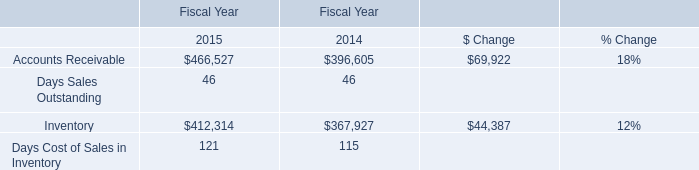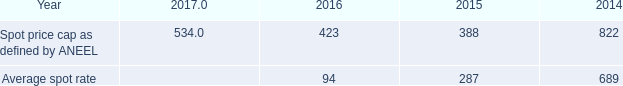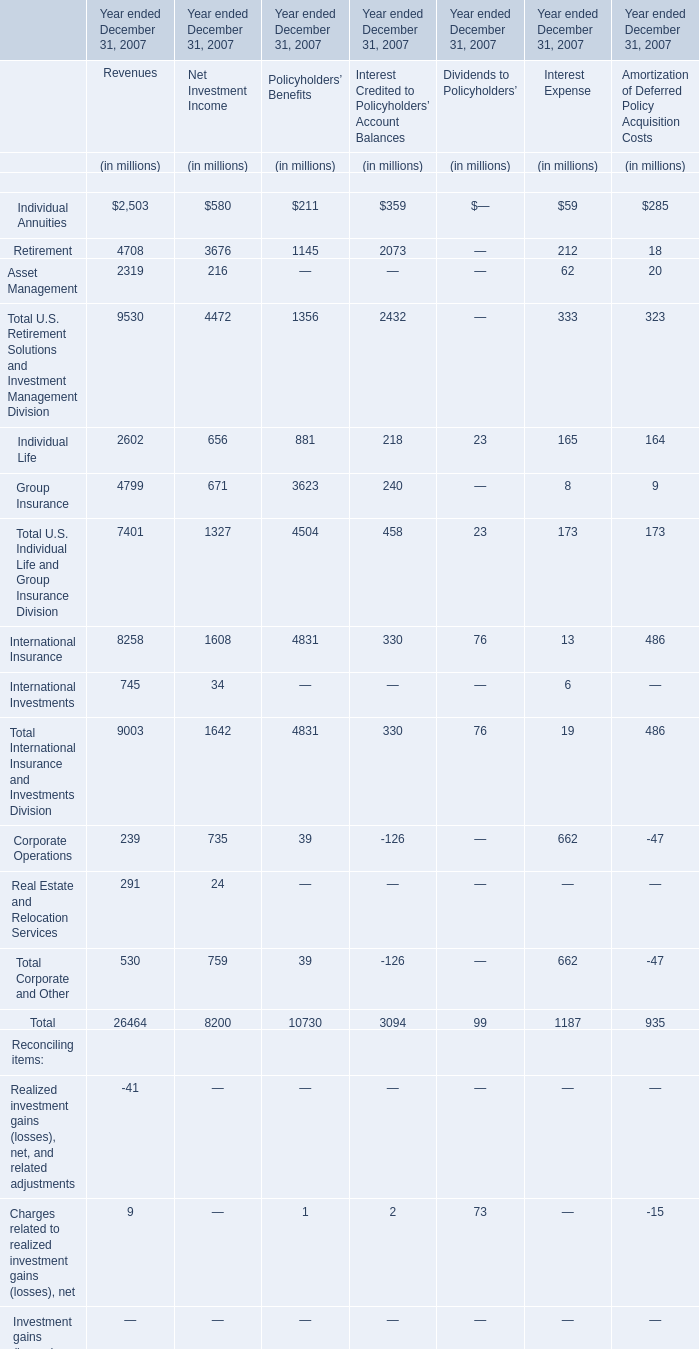what was the percentage change in the average spot rate between 2014 to 2015? 
Computations: ((287 - 689) / 689)
Answer: -0.58345. 